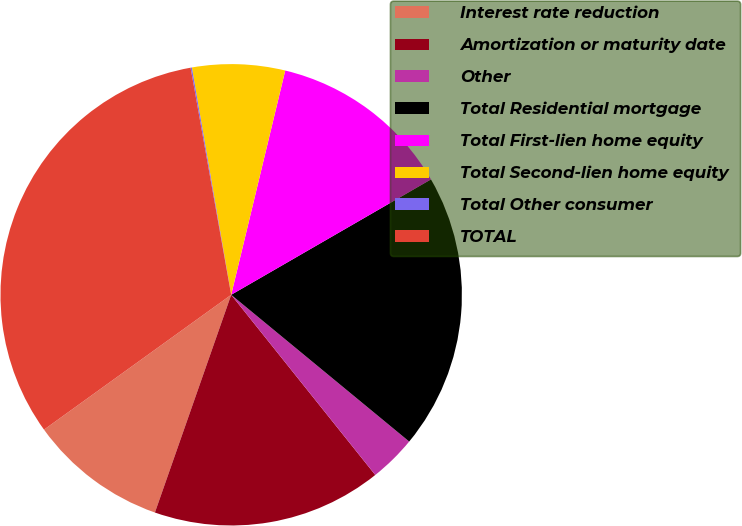<chart> <loc_0><loc_0><loc_500><loc_500><pie_chart><fcel>Interest rate reduction<fcel>Amortization or maturity date<fcel>Other<fcel>Total Residential mortgage<fcel>Total First-lien home equity<fcel>Total Second-lien home equity<fcel>Total Other consumer<fcel>TOTAL<nl><fcel>9.7%<fcel>16.1%<fcel>3.29%<fcel>19.31%<fcel>12.9%<fcel>6.49%<fcel>0.09%<fcel>32.12%<nl></chart> 